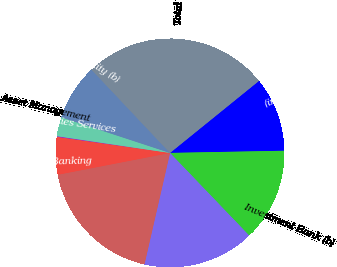Convert chart. <chart><loc_0><loc_0><loc_500><loc_500><pie_chart><fcel>(in millions)<fcel>Investment Bank (b)<fcel>Retail Financial Services<fcel>Card Services<fcel>Commercial Banking<fcel>Treasury & Securities Services<fcel>Asset Management<fcel>Corporate/Private Equity (b)<fcel>Total<nl><fcel>10.53%<fcel>13.14%<fcel>15.75%<fcel>18.36%<fcel>5.31%<fcel>0.09%<fcel>2.7%<fcel>7.92%<fcel>26.2%<nl></chart> 